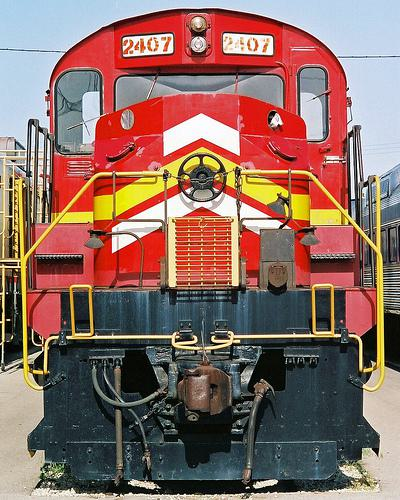Could you describe the setting where this train is located? Certainly! The train is parked in what looks like a railyard or maintenance facility, as indicated by the presence of fueling stations and maintenance equipment in the background. The absence of passengers or baggage carts further implies that this location is more for operational purposes than for boarding travelers. 